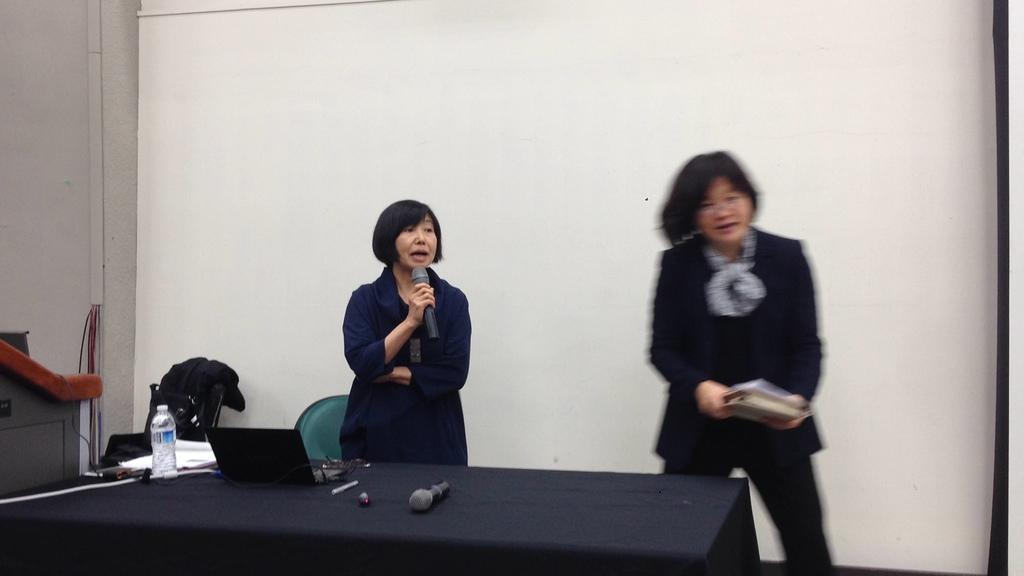Describe this image in one or two sentences. In this picture I can see two persons standing, a person holding a book, another person holding a mike, there is a bottle, papers, laptop, spectacles, mike and some other objects on the table, there are chairs and cables, and in the background there is a wall or screen. 